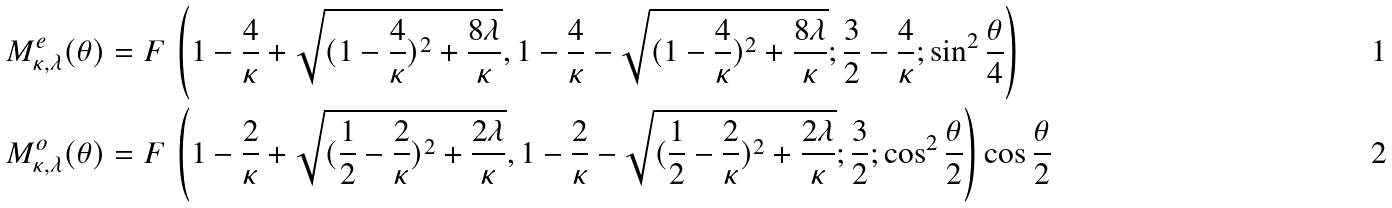<formula> <loc_0><loc_0><loc_500><loc_500>M ^ { e } _ { \kappa , \lambda } ( \theta ) & = F \, \left ( 1 - \frac { 4 } { \kappa } + \sqrt { ( 1 - \frac { 4 } { \kappa } ) ^ { 2 } + \frac { 8 \lambda } { \kappa } } , 1 - \frac { 4 } { \kappa } - \sqrt { ( 1 - \frac { 4 } { \kappa } ) ^ { 2 } + \frac { 8 \lambda } { \kappa } } ; \frac { 3 } { 2 } - \frac { 4 } { \kappa } ; \sin ^ { 2 } \frac { \theta } { 4 } \right ) \\ M ^ { o } _ { \kappa , \lambda } ( \theta ) & = F \, \left ( 1 - \frac { 2 } { \kappa } + \sqrt { ( \frac { 1 } { 2 } - \frac { 2 } { \kappa } ) ^ { 2 } + \frac { 2 \lambda } { \kappa } } , 1 - \frac { 2 } { \kappa } - \sqrt { ( \frac { 1 } { 2 } - \frac { 2 } { \kappa } ) ^ { 2 } + \frac { 2 \lambda } { \kappa } } ; \frac { 3 } { 2 } ; \cos ^ { 2 } \frac { \theta } { 2 } \right ) \cos \frac { \theta } { 2 }</formula> 